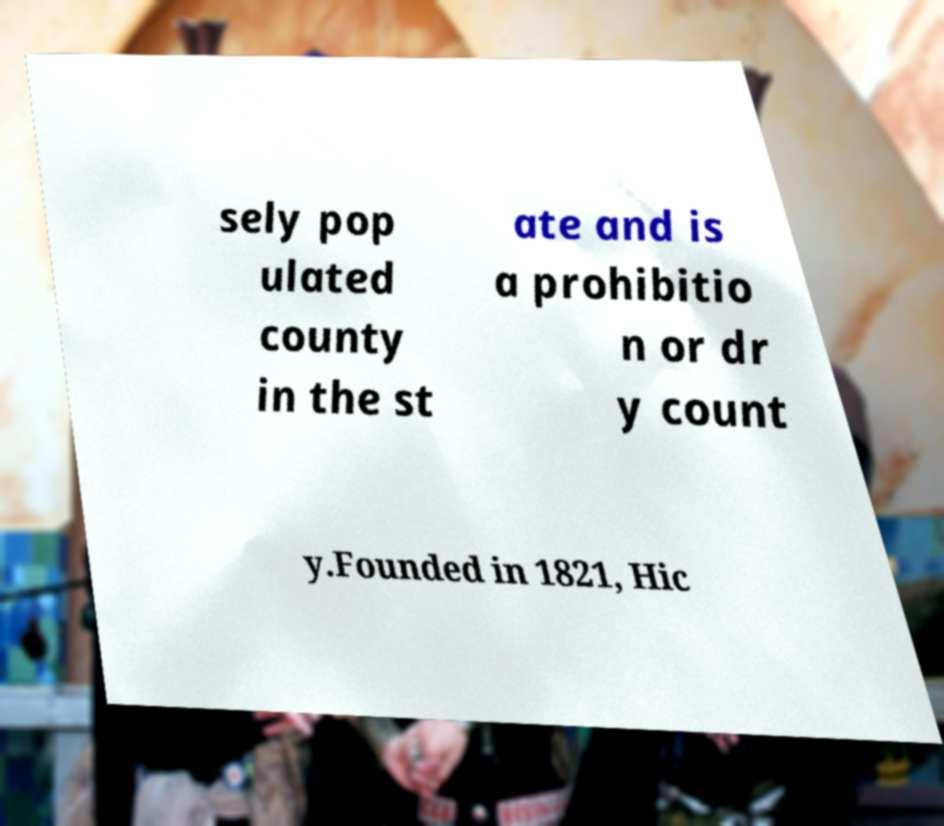For documentation purposes, I need the text within this image transcribed. Could you provide that? sely pop ulated county in the st ate and is a prohibitio n or dr y count y.Founded in 1821, Hic 